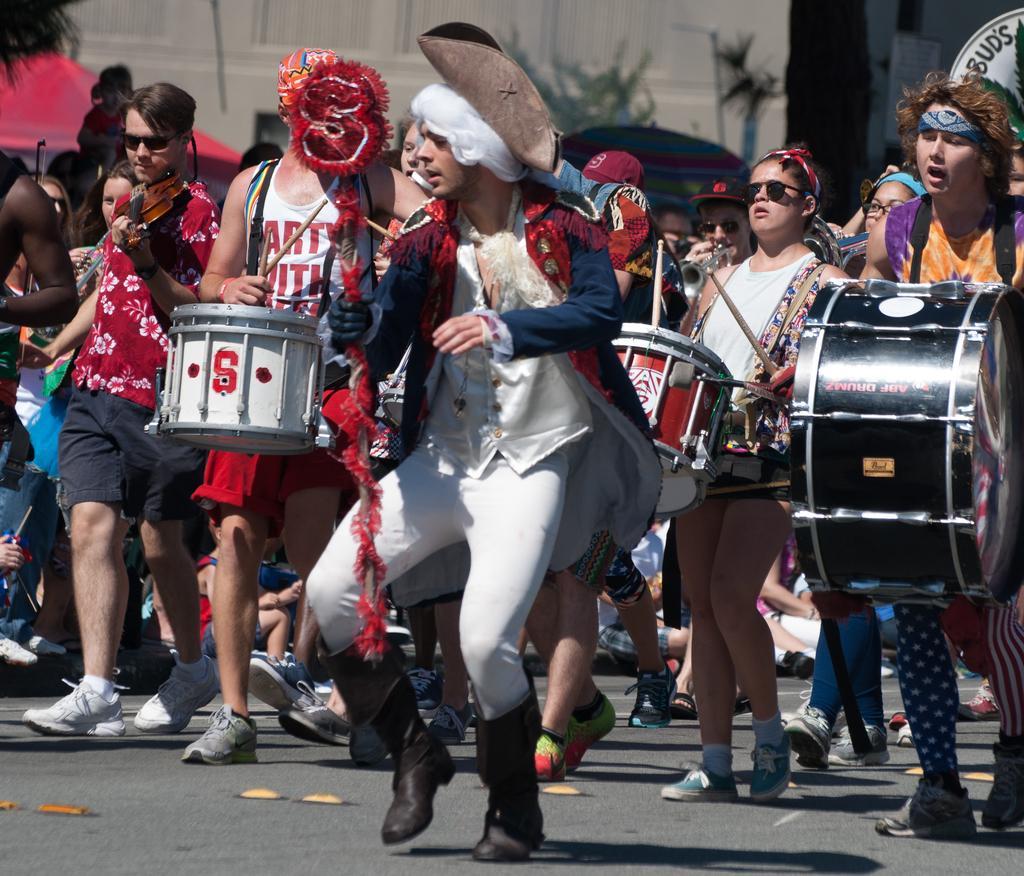Please provide a concise description of this image. In this picture we can see some persons playing musical instruments on the road. 